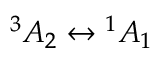Convert formula to latex. <formula><loc_0><loc_0><loc_500><loc_500>{ } ^ { 3 } A _ { 2 } ^ { 1 } A _ { 1 }</formula> 